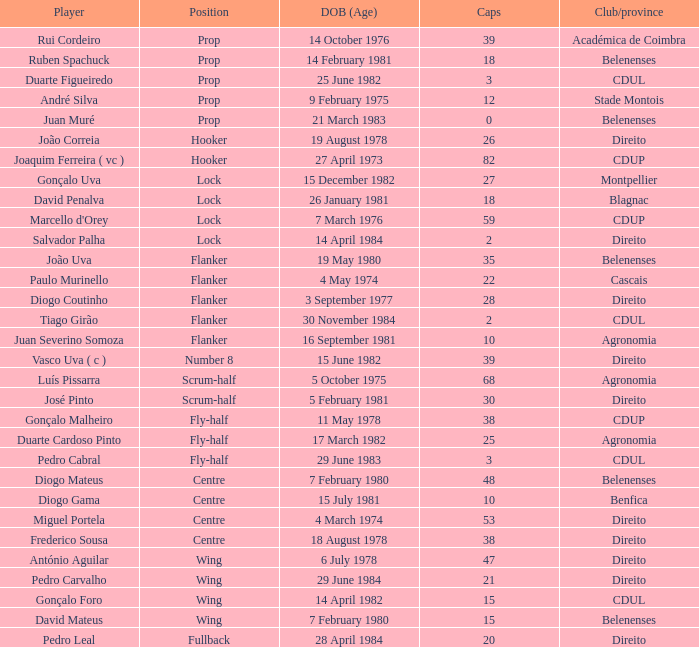Write the full table. {'header': ['Player', 'Position', 'DOB (Age)', 'Caps', 'Club/province'], 'rows': [['Rui Cordeiro', 'Prop', '14 October 1976', '39', 'Académica de Coimbra'], ['Ruben Spachuck', 'Prop', '14 February 1981', '18', 'Belenenses'], ['Duarte Figueiredo', 'Prop', '25 June 1982', '3', 'CDUL'], ['André Silva', 'Prop', '9 February 1975', '12', 'Stade Montois'], ['Juan Muré', 'Prop', '21 March 1983', '0', 'Belenenses'], ['João Correia', 'Hooker', '19 August 1978', '26', 'Direito'], ['Joaquim Ferreira ( vc )', 'Hooker', '27 April 1973', '82', 'CDUP'], ['Gonçalo Uva', 'Lock', '15 December 1982', '27', 'Montpellier'], ['David Penalva', 'Lock', '26 January 1981', '18', 'Blagnac'], ["Marcello d'Orey", 'Lock', '7 March 1976', '59', 'CDUP'], ['Salvador Palha', 'Lock', '14 April 1984', '2', 'Direito'], ['João Uva', 'Flanker', '19 May 1980', '35', 'Belenenses'], ['Paulo Murinello', 'Flanker', '4 May 1974', '22', 'Cascais'], ['Diogo Coutinho', 'Flanker', '3 September 1977', '28', 'Direito'], ['Tiago Girão', 'Flanker', '30 November 1984', '2', 'CDUL'], ['Juan Severino Somoza', 'Flanker', '16 September 1981', '10', 'Agronomia'], ['Vasco Uva ( c )', 'Number 8', '15 June 1982', '39', 'Direito'], ['Luís Pissarra', 'Scrum-half', '5 October 1975', '68', 'Agronomia'], ['José Pinto', 'Scrum-half', '5 February 1981', '30', 'Direito'], ['Gonçalo Malheiro', 'Fly-half', '11 May 1978', '38', 'CDUP'], ['Duarte Cardoso Pinto', 'Fly-half', '17 March 1982', '25', 'Agronomia'], ['Pedro Cabral', 'Fly-half', '29 June 1983', '3', 'CDUL'], ['Diogo Mateus', 'Centre', '7 February 1980', '48', 'Belenenses'], ['Diogo Gama', 'Centre', '15 July 1981', '10', 'Benfica'], ['Miguel Portela', 'Centre', '4 March 1974', '53', 'Direito'], ['Frederico Sousa', 'Centre', '18 August 1978', '38', 'Direito'], ['António Aguilar', 'Wing', '6 July 1978', '47', 'Direito'], ['Pedro Carvalho', 'Wing', '29 June 1984', '21', 'Direito'], ['Gonçalo Foro', 'Wing', '14 April 1982', '15', 'CDUL'], ['David Mateus', 'Wing', '7 February 1980', '15', 'Belenenses'], ['Pedro Leal', 'Fullback', '28 April 1984', '20', 'Direito']]} Which player has a Club/province of direito, less than 21 caps, and a Position of lock? Salvador Palha. 